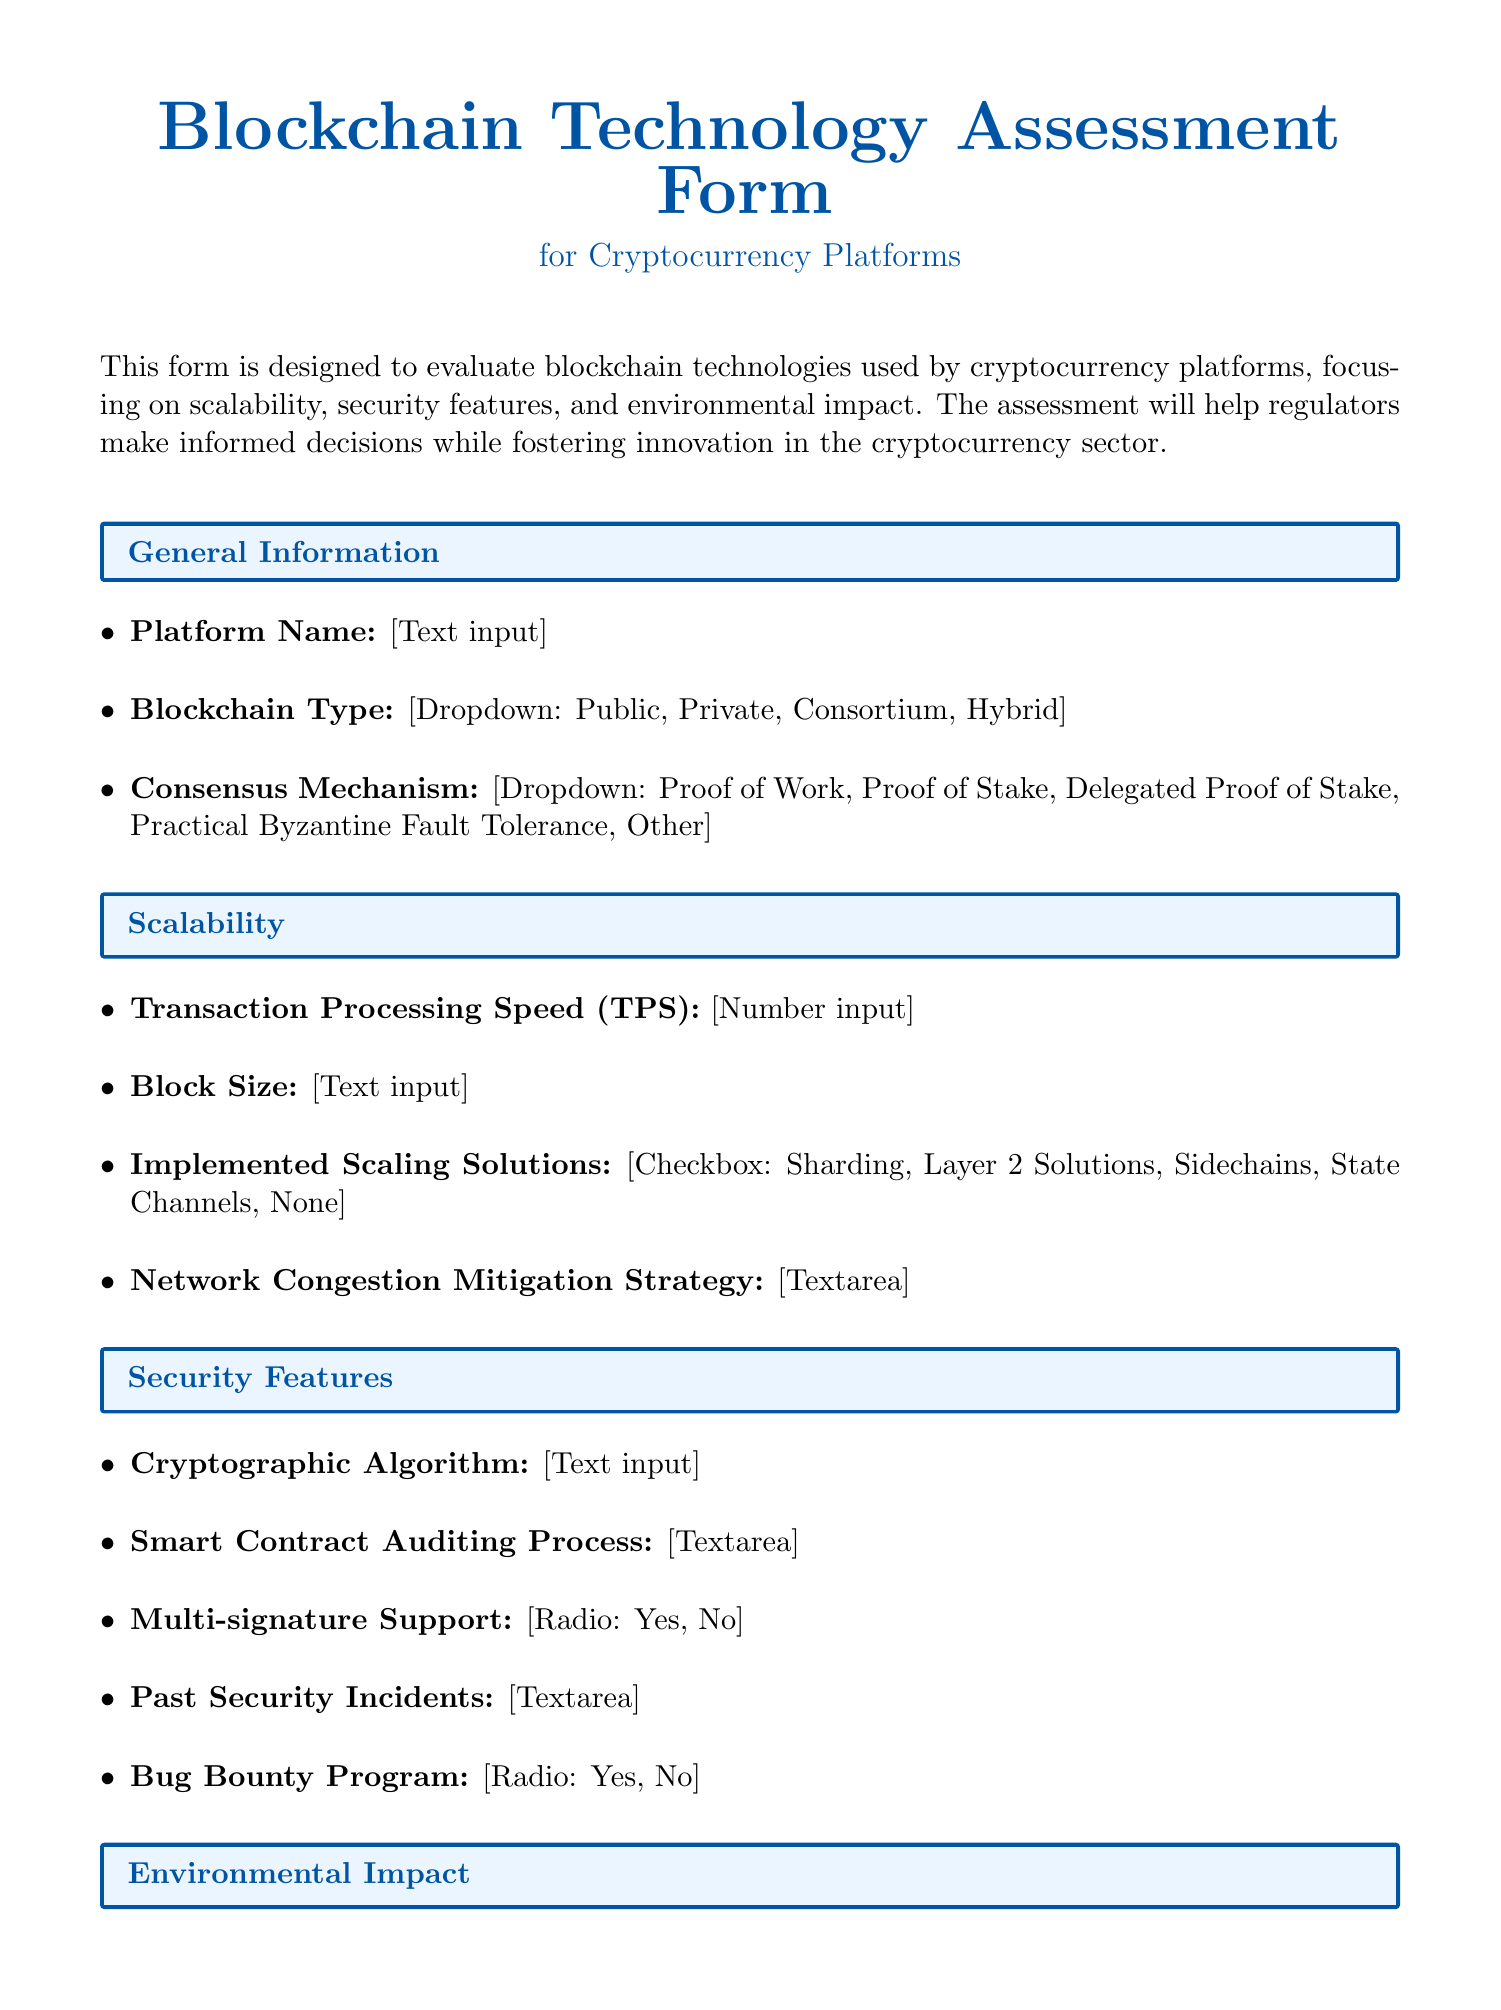what is the title of the document? The document is titled "Blockchain Technology Assessment Form for Cryptocurrency Platforms," as mentioned at the beginning of the document.
Answer: Blockchain Technology Assessment Form for Cryptocurrency Platforms what is the required field for "Platform Name"? "Platform Name" is a required text input field, as stated in the General Information section.
Answer: Text what is the maximum number of options available for the Consensus Mechanism? The document lists five options for the Consensus Mechanism dropdown.
Answer: Five what is the energy consumption measurement unit? The field specifies "kWh per transaction" as the unit of measurement for energy consumption.
Answer: kWh per transaction how many sections are in the document? The document contains six sections, which can be counted from the structure of the form.
Answer: Six what is the value of Renewable Energy Usage indicated as a required field? The document specifies that Renewable Energy Usage is a number input required field.
Answer: Number Input what type of support is mentioned under Security Features? Multi-signature Support is labeled as a radio option under the Security Features section.
Answer: Multi-signature Support which characteristics does the network congestion mitigation strategy include? The network congestion mitigation strategy is a required textarea input field where specifics have to be described.
Answer: Textarea what compliance aspect must be addressed according to the Regulatory Compliance section? KYC/AML Procedures are required to be described in the Regulatory Compliance section.
Answer: KYC/AML Procedures 